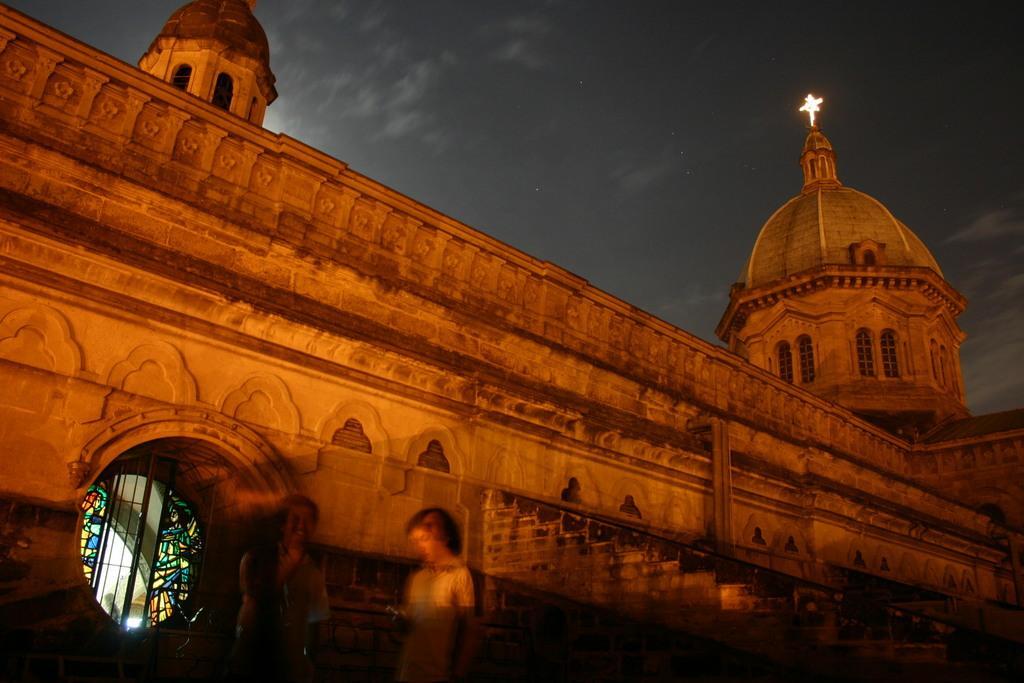Please provide a concise description of this image. In this picture we can observe a building. There is a dome on the building. On this home we can observe cross. There are two persons standing in this picture. In the background there is a sky. 